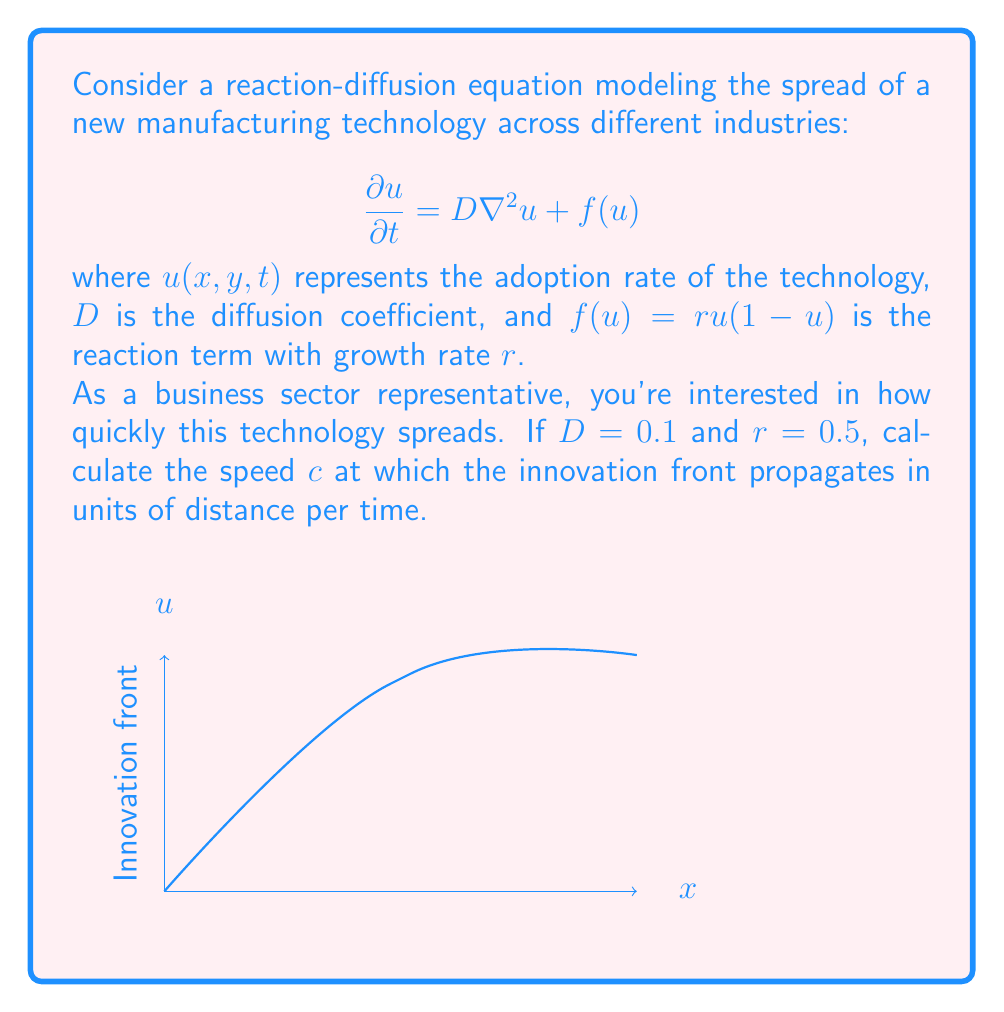What is the answer to this math problem? To solve this problem, we'll follow these steps:

1) For a reaction-diffusion equation of the form $\frac{\partial u}{\partial t} = D\nabla^2u + f(u)$ with $f(u)=ru(1-u)$, the speed of propagation is given by the Fisher-KPP formula:

   $$c = 2\sqrt{Dr}$$

2) We're given:
   $D = 0.1$ (diffusion coefficient)
   $r = 0.5$ (growth rate)

3) Let's substitute these values into the formula:

   $$c = 2\sqrt{(0.1)(0.5)}$$

4) Simplify under the square root:

   $$c = 2\sqrt{0.05}$$

5) Calculate the square root:

   $$c = 2(0.2236)$$

6) Multiply:

   $$c = 0.4472$$

Therefore, the innovation front propagates at a speed of approximately 0.4472 units of distance per unit of time.
Answer: $c \approx 0.4472$ 